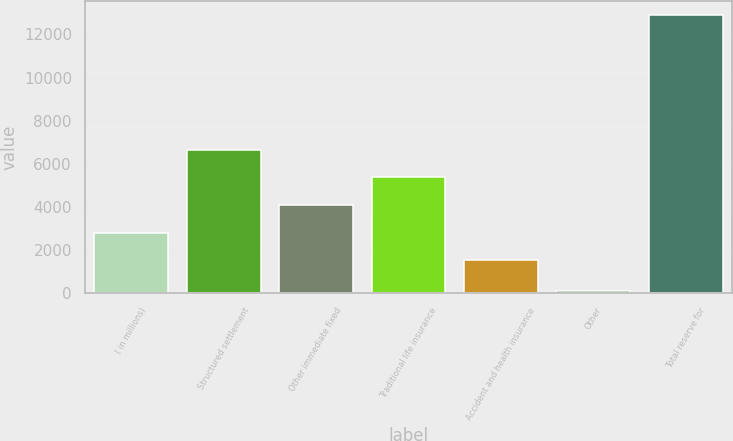Convert chart. <chart><loc_0><loc_0><loc_500><loc_500><bar_chart><fcel>( in millions)<fcel>Structured settlement<fcel>Other immediate fixed<fcel>Traditional life insurance<fcel>Accident and health insurance<fcel>Other<fcel>Total reserve for<nl><fcel>2795.8<fcel>6641.2<fcel>4077.6<fcel>5359.4<fcel>1514<fcel>92<fcel>12910<nl></chart> 